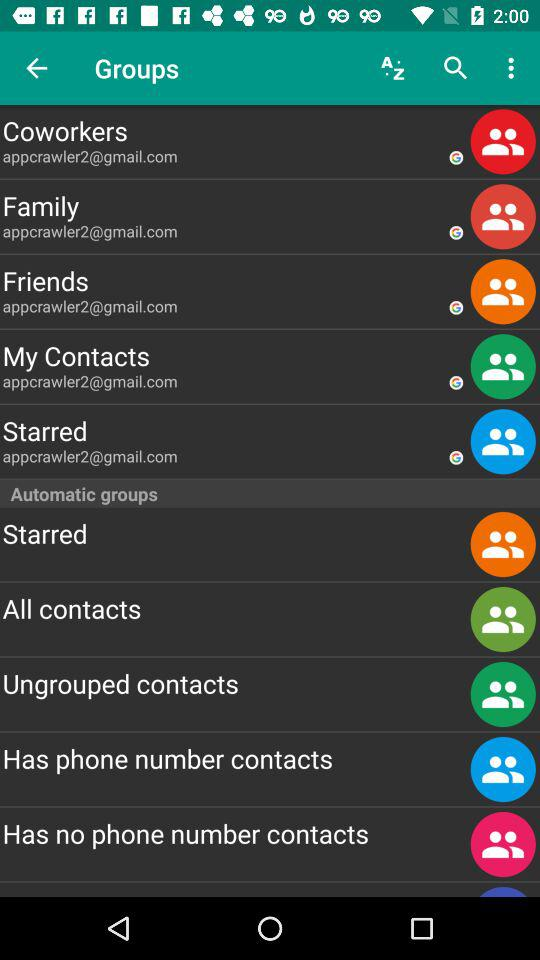What is the email address of the "Coworkers"? The email address of the "Coworkers" is appcrawler2@gmail.com. 